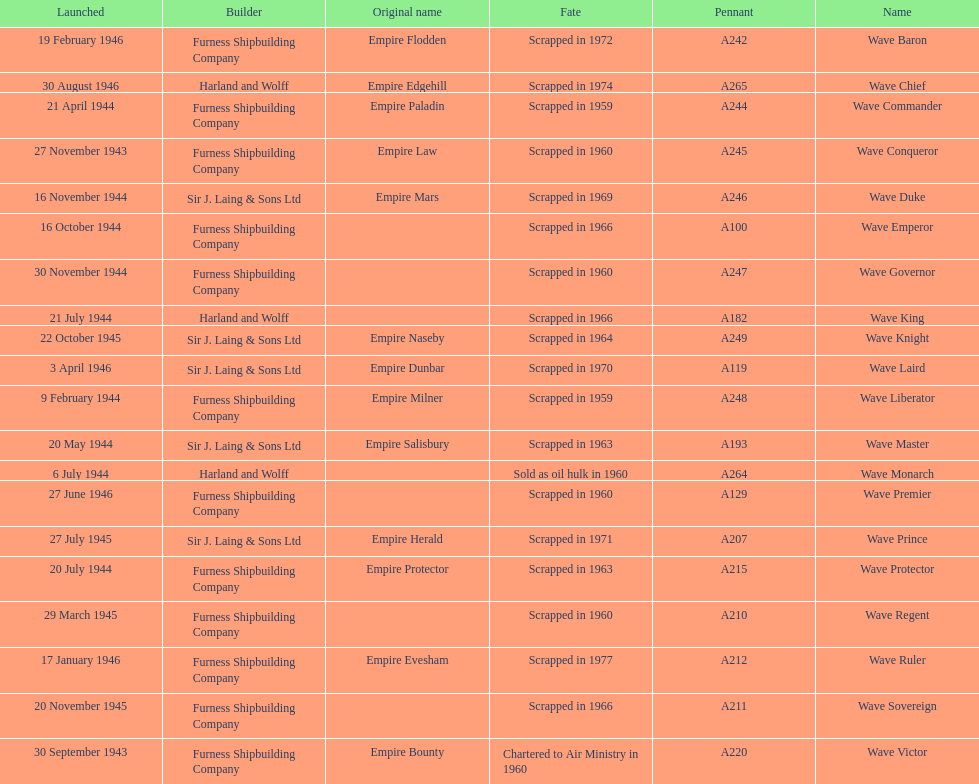Parse the table in full. {'header': ['Launched', 'Builder', 'Original name', 'Fate', 'Pennant', 'Name'], 'rows': [['19 February 1946', 'Furness Shipbuilding Company', 'Empire Flodden', 'Scrapped in 1972', 'A242', 'Wave Baron'], ['30 August 1946', 'Harland and Wolff', 'Empire Edgehill', 'Scrapped in 1974', 'A265', 'Wave Chief'], ['21 April 1944', 'Furness Shipbuilding Company', 'Empire Paladin', 'Scrapped in 1959', 'A244', 'Wave Commander'], ['27 November 1943', 'Furness Shipbuilding Company', 'Empire Law', 'Scrapped in 1960', 'A245', 'Wave Conqueror'], ['16 November 1944', 'Sir J. Laing & Sons Ltd', 'Empire Mars', 'Scrapped in 1969', 'A246', 'Wave Duke'], ['16 October 1944', 'Furness Shipbuilding Company', '', 'Scrapped in 1966', 'A100', 'Wave Emperor'], ['30 November 1944', 'Furness Shipbuilding Company', '', 'Scrapped in 1960', 'A247', 'Wave Governor'], ['21 July 1944', 'Harland and Wolff', '', 'Scrapped in 1966', 'A182', 'Wave King'], ['22 October 1945', 'Sir J. Laing & Sons Ltd', 'Empire Naseby', 'Scrapped in 1964', 'A249', 'Wave Knight'], ['3 April 1946', 'Sir J. Laing & Sons Ltd', 'Empire Dunbar', 'Scrapped in 1970', 'A119', 'Wave Laird'], ['9 February 1944', 'Furness Shipbuilding Company', 'Empire Milner', 'Scrapped in 1959', 'A248', 'Wave Liberator'], ['20 May 1944', 'Sir J. Laing & Sons Ltd', 'Empire Salisbury', 'Scrapped in 1963', 'A193', 'Wave Master'], ['6 July 1944', 'Harland and Wolff', '', 'Sold as oil hulk in 1960', 'A264', 'Wave Monarch'], ['27 June 1946', 'Furness Shipbuilding Company', '', 'Scrapped in 1960', 'A129', 'Wave Premier'], ['27 July 1945', 'Sir J. Laing & Sons Ltd', 'Empire Herald', 'Scrapped in 1971', 'A207', 'Wave Prince'], ['20 July 1944', 'Furness Shipbuilding Company', 'Empire Protector', 'Scrapped in 1963', 'A215', 'Wave Protector'], ['29 March 1945', 'Furness Shipbuilding Company', '', 'Scrapped in 1960', 'A210', 'Wave Regent'], ['17 January 1946', 'Furness Shipbuilding Company', 'Empire Evesham', 'Scrapped in 1977', 'A212', 'Wave Ruler'], ['20 November 1945', 'Furness Shipbuilding Company', '', 'Scrapped in 1966', 'A211', 'Wave Sovereign'], ['30 September 1943', 'Furness Shipbuilding Company', 'Empire Bounty', 'Chartered to Air Ministry in 1960', 'A220', 'Wave Victor']]} Which other ship was launched in the same year as the wave victor? Wave Conqueror. 